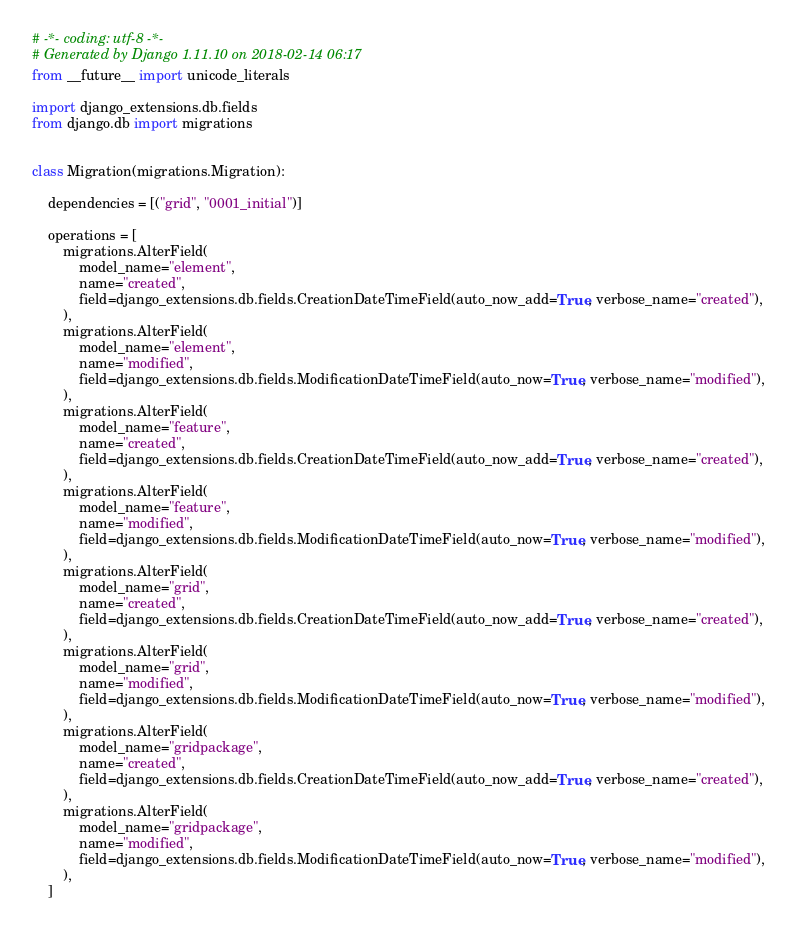Convert code to text. <code><loc_0><loc_0><loc_500><loc_500><_Python_># -*- coding: utf-8 -*-
# Generated by Django 1.11.10 on 2018-02-14 06:17
from __future__ import unicode_literals

import django_extensions.db.fields
from django.db import migrations


class Migration(migrations.Migration):

    dependencies = [("grid", "0001_initial")]

    operations = [
        migrations.AlterField(
            model_name="element",
            name="created",
            field=django_extensions.db.fields.CreationDateTimeField(auto_now_add=True, verbose_name="created"),
        ),
        migrations.AlterField(
            model_name="element",
            name="modified",
            field=django_extensions.db.fields.ModificationDateTimeField(auto_now=True, verbose_name="modified"),
        ),
        migrations.AlterField(
            model_name="feature",
            name="created",
            field=django_extensions.db.fields.CreationDateTimeField(auto_now_add=True, verbose_name="created"),
        ),
        migrations.AlterField(
            model_name="feature",
            name="modified",
            field=django_extensions.db.fields.ModificationDateTimeField(auto_now=True, verbose_name="modified"),
        ),
        migrations.AlterField(
            model_name="grid",
            name="created",
            field=django_extensions.db.fields.CreationDateTimeField(auto_now_add=True, verbose_name="created"),
        ),
        migrations.AlterField(
            model_name="grid",
            name="modified",
            field=django_extensions.db.fields.ModificationDateTimeField(auto_now=True, verbose_name="modified"),
        ),
        migrations.AlterField(
            model_name="gridpackage",
            name="created",
            field=django_extensions.db.fields.CreationDateTimeField(auto_now_add=True, verbose_name="created"),
        ),
        migrations.AlterField(
            model_name="gridpackage",
            name="modified",
            field=django_extensions.db.fields.ModificationDateTimeField(auto_now=True, verbose_name="modified"),
        ),
    ]
</code> 